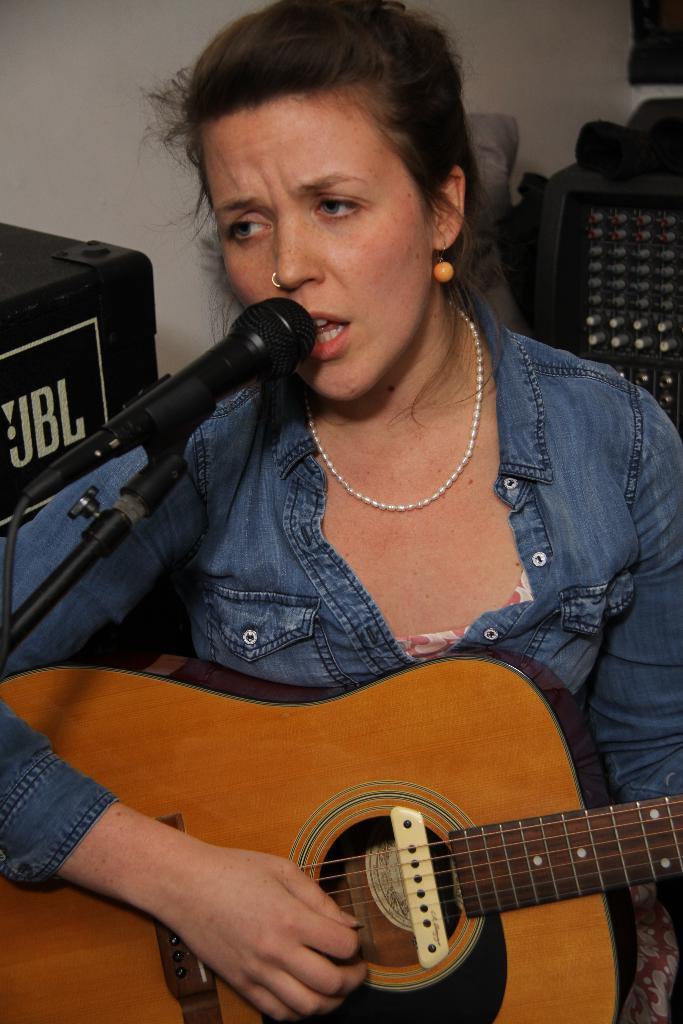Can you describe this image briefly? As we can see in the image there is a woman holding guitar and singing on mic. 